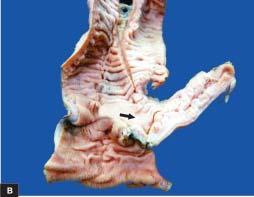does the lesions show an outpouching which on section is seen communicating with the intestinal lumen?
Answer the question using a single word or phrase. No 